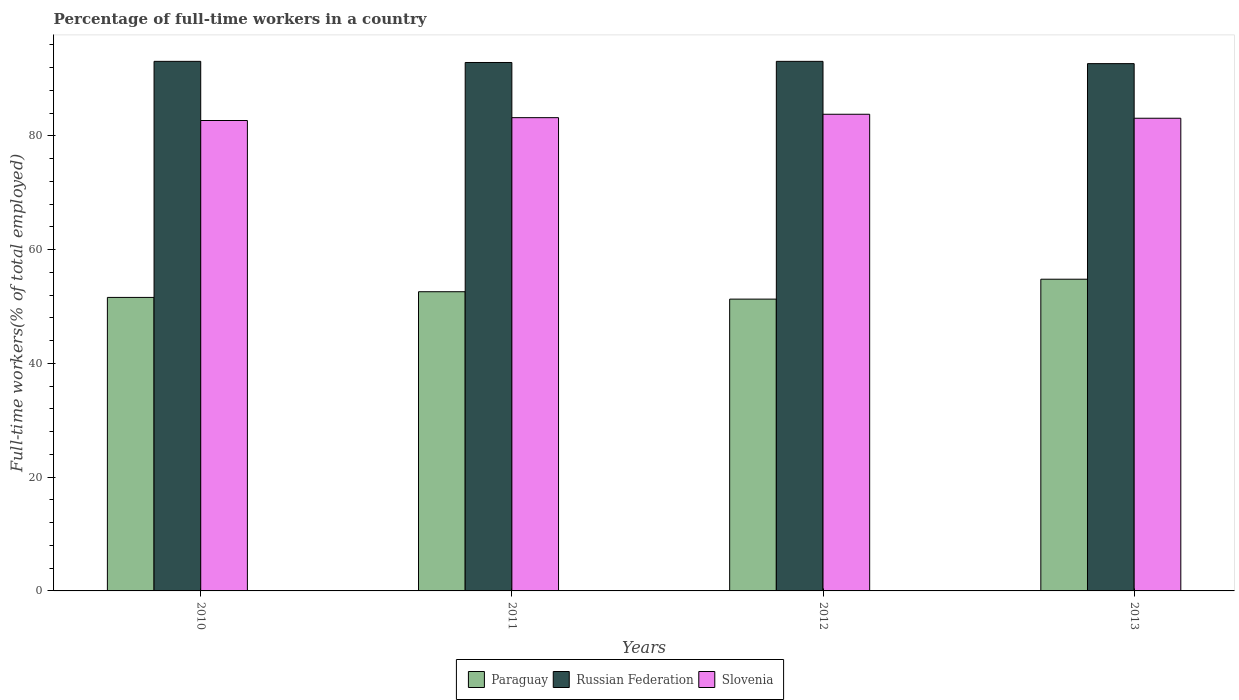Are the number of bars per tick equal to the number of legend labels?
Give a very brief answer. Yes. How many bars are there on the 3rd tick from the left?
Make the answer very short. 3. What is the percentage of full-time workers in Russian Federation in 2011?
Give a very brief answer. 92.9. Across all years, what is the maximum percentage of full-time workers in Paraguay?
Your answer should be very brief. 54.8. Across all years, what is the minimum percentage of full-time workers in Paraguay?
Your answer should be compact. 51.3. What is the total percentage of full-time workers in Slovenia in the graph?
Provide a succinct answer. 332.8. What is the difference between the percentage of full-time workers in Slovenia in 2012 and that in 2013?
Your answer should be compact. 0.7. What is the difference between the percentage of full-time workers in Slovenia in 2010 and the percentage of full-time workers in Russian Federation in 2012?
Keep it short and to the point. -10.4. What is the average percentage of full-time workers in Paraguay per year?
Give a very brief answer. 52.57. In the year 2012, what is the difference between the percentage of full-time workers in Slovenia and percentage of full-time workers in Russian Federation?
Ensure brevity in your answer.  -9.3. What is the ratio of the percentage of full-time workers in Russian Federation in 2010 to that in 2013?
Make the answer very short. 1. Is the percentage of full-time workers in Russian Federation in 2010 less than that in 2011?
Your answer should be compact. No. Is the difference between the percentage of full-time workers in Slovenia in 2010 and 2012 greater than the difference between the percentage of full-time workers in Russian Federation in 2010 and 2012?
Offer a very short reply. No. What is the difference between the highest and the second highest percentage of full-time workers in Slovenia?
Your answer should be compact. 0.6. What is the difference between the highest and the lowest percentage of full-time workers in Paraguay?
Your answer should be very brief. 3.5. In how many years, is the percentage of full-time workers in Slovenia greater than the average percentage of full-time workers in Slovenia taken over all years?
Ensure brevity in your answer.  1. What does the 2nd bar from the left in 2012 represents?
Offer a very short reply. Russian Federation. What does the 3rd bar from the right in 2012 represents?
Your answer should be compact. Paraguay. Is it the case that in every year, the sum of the percentage of full-time workers in Russian Federation and percentage of full-time workers in Slovenia is greater than the percentage of full-time workers in Paraguay?
Offer a terse response. Yes. What is the difference between two consecutive major ticks on the Y-axis?
Provide a short and direct response. 20. Does the graph contain any zero values?
Your answer should be compact. No. What is the title of the graph?
Ensure brevity in your answer.  Percentage of full-time workers in a country. What is the label or title of the Y-axis?
Offer a terse response. Full-time workers(% of total employed). What is the Full-time workers(% of total employed) of Paraguay in 2010?
Provide a succinct answer. 51.6. What is the Full-time workers(% of total employed) of Russian Federation in 2010?
Your answer should be compact. 93.1. What is the Full-time workers(% of total employed) of Slovenia in 2010?
Your response must be concise. 82.7. What is the Full-time workers(% of total employed) of Paraguay in 2011?
Provide a short and direct response. 52.6. What is the Full-time workers(% of total employed) of Russian Federation in 2011?
Your answer should be very brief. 92.9. What is the Full-time workers(% of total employed) of Slovenia in 2011?
Your answer should be compact. 83.2. What is the Full-time workers(% of total employed) of Paraguay in 2012?
Keep it short and to the point. 51.3. What is the Full-time workers(% of total employed) in Russian Federation in 2012?
Your answer should be compact. 93.1. What is the Full-time workers(% of total employed) in Slovenia in 2012?
Offer a terse response. 83.8. What is the Full-time workers(% of total employed) in Paraguay in 2013?
Ensure brevity in your answer.  54.8. What is the Full-time workers(% of total employed) of Russian Federation in 2013?
Offer a very short reply. 92.7. What is the Full-time workers(% of total employed) in Slovenia in 2013?
Your answer should be very brief. 83.1. Across all years, what is the maximum Full-time workers(% of total employed) of Paraguay?
Offer a very short reply. 54.8. Across all years, what is the maximum Full-time workers(% of total employed) in Russian Federation?
Give a very brief answer. 93.1. Across all years, what is the maximum Full-time workers(% of total employed) of Slovenia?
Make the answer very short. 83.8. Across all years, what is the minimum Full-time workers(% of total employed) of Paraguay?
Make the answer very short. 51.3. Across all years, what is the minimum Full-time workers(% of total employed) in Russian Federation?
Your answer should be very brief. 92.7. Across all years, what is the minimum Full-time workers(% of total employed) in Slovenia?
Provide a succinct answer. 82.7. What is the total Full-time workers(% of total employed) of Paraguay in the graph?
Make the answer very short. 210.3. What is the total Full-time workers(% of total employed) in Russian Federation in the graph?
Your answer should be very brief. 371.8. What is the total Full-time workers(% of total employed) in Slovenia in the graph?
Ensure brevity in your answer.  332.8. What is the difference between the Full-time workers(% of total employed) in Paraguay in 2010 and that in 2012?
Keep it short and to the point. 0.3. What is the difference between the Full-time workers(% of total employed) in Russian Federation in 2010 and that in 2012?
Give a very brief answer. 0. What is the difference between the Full-time workers(% of total employed) of Slovenia in 2010 and that in 2013?
Ensure brevity in your answer.  -0.4. What is the difference between the Full-time workers(% of total employed) in Slovenia in 2011 and that in 2012?
Ensure brevity in your answer.  -0.6. What is the difference between the Full-time workers(% of total employed) of Slovenia in 2011 and that in 2013?
Your response must be concise. 0.1. What is the difference between the Full-time workers(% of total employed) of Russian Federation in 2012 and that in 2013?
Provide a short and direct response. 0.4. What is the difference between the Full-time workers(% of total employed) in Slovenia in 2012 and that in 2013?
Provide a succinct answer. 0.7. What is the difference between the Full-time workers(% of total employed) of Paraguay in 2010 and the Full-time workers(% of total employed) of Russian Federation in 2011?
Keep it short and to the point. -41.3. What is the difference between the Full-time workers(% of total employed) in Paraguay in 2010 and the Full-time workers(% of total employed) in Slovenia in 2011?
Your answer should be very brief. -31.6. What is the difference between the Full-time workers(% of total employed) of Russian Federation in 2010 and the Full-time workers(% of total employed) of Slovenia in 2011?
Your answer should be very brief. 9.9. What is the difference between the Full-time workers(% of total employed) in Paraguay in 2010 and the Full-time workers(% of total employed) in Russian Federation in 2012?
Your response must be concise. -41.5. What is the difference between the Full-time workers(% of total employed) in Paraguay in 2010 and the Full-time workers(% of total employed) in Slovenia in 2012?
Give a very brief answer. -32.2. What is the difference between the Full-time workers(% of total employed) in Russian Federation in 2010 and the Full-time workers(% of total employed) in Slovenia in 2012?
Keep it short and to the point. 9.3. What is the difference between the Full-time workers(% of total employed) of Paraguay in 2010 and the Full-time workers(% of total employed) of Russian Federation in 2013?
Provide a succinct answer. -41.1. What is the difference between the Full-time workers(% of total employed) in Paraguay in 2010 and the Full-time workers(% of total employed) in Slovenia in 2013?
Your response must be concise. -31.5. What is the difference between the Full-time workers(% of total employed) of Paraguay in 2011 and the Full-time workers(% of total employed) of Russian Federation in 2012?
Offer a terse response. -40.5. What is the difference between the Full-time workers(% of total employed) in Paraguay in 2011 and the Full-time workers(% of total employed) in Slovenia in 2012?
Your response must be concise. -31.2. What is the difference between the Full-time workers(% of total employed) of Russian Federation in 2011 and the Full-time workers(% of total employed) of Slovenia in 2012?
Offer a very short reply. 9.1. What is the difference between the Full-time workers(% of total employed) of Paraguay in 2011 and the Full-time workers(% of total employed) of Russian Federation in 2013?
Offer a very short reply. -40.1. What is the difference between the Full-time workers(% of total employed) of Paraguay in 2011 and the Full-time workers(% of total employed) of Slovenia in 2013?
Provide a succinct answer. -30.5. What is the difference between the Full-time workers(% of total employed) in Russian Federation in 2011 and the Full-time workers(% of total employed) in Slovenia in 2013?
Your answer should be compact. 9.8. What is the difference between the Full-time workers(% of total employed) of Paraguay in 2012 and the Full-time workers(% of total employed) of Russian Federation in 2013?
Your answer should be compact. -41.4. What is the difference between the Full-time workers(% of total employed) of Paraguay in 2012 and the Full-time workers(% of total employed) of Slovenia in 2013?
Give a very brief answer. -31.8. What is the average Full-time workers(% of total employed) of Paraguay per year?
Offer a terse response. 52.58. What is the average Full-time workers(% of total employed) of Russian Federation per year?
Keep it short and to the point. 92.95. What is the average Full-time workers(% of total employed) of Slovenia per year?
Offer a terse response. 83.2. In the year 2010, what is the difference between the Full-time workers(% of total employed) of Paraguay and Full-time workers(% of total employed) of Russian Federation?
Ensure brevity in your answer.  -41.5. In the year 2010, what is the difference between the Full-time workers(% of total employed) of Paraguay and Full-time workers(% of total employed) of Slovenia?
Provide a succinct answer. -31.1. In the year 2010, what is the difference between the Full-time workers(% of total employed) in Russian Federation and Full-time workers(% of total employed) in Slovenia?
Your response must be concise. 10.4. In the year 2011, what is the difference between the Full-time workers(% of total employed) of Paraguay and Full-time workers(% of total employed) of Russian Federation?
Make the answer very short. -40.3. In the year 2011, what is the difference between the Full-time workers(% of total employed) in Paraguay and Full-time workers(% of total employed) in Slovenia?
Offer a very short reply. -30.6. In the year 2012, what is the difference between the Full-time workers(% of total employed) in Paraguay and Full-time workers(% of total employed) in Russian Federation?
Your answer should be very brief. -41.8. In the year 2012, what is the difference between the Full-time workers(% of total employed) of Paraguay and Full-time workers(% of total employed) of Slovenia?
Make the answer very short. -32.5. In the year 2013, what is the difference between the Full-time workers(% of total employed) in Paraguay and Full-time workers(% of total employed) in Russian Federation?
Give a very brief answer. -37.9. In the year 2013, what is the difference between the Full-time workers(% of total employed) of Paraguay and Full-time workers(% of total employed) of Slovenia?
Provide a short and direct response. -28.3. In the year 2013, what is the difference between the Full-time workers(% of total employed) in Russian Federation and Full-time workers(% of total employed) in Slovenia?
Keep it short and to the point. 9.6. What is the ratio of the Full-time workers(% of total employed) of Russian Federation in 2010 to that in 2011?
Give a very brief answer. 1. What is the ratio of the Full-time workers(% of total employed) of Slovenia in 2010 to that in 2011?
Provide a succinct answer. 0.99. What is the ratio of the Full-time workers(% of total employed) of Paraguay in 2010 to that in 2012?
Make the answer very short. 1.01. What is the ratio of the Full-time workers(% of total employed) in Russian Federation in 2010 to that in 2012?
Offer a very short reply. 1. What is the ratio of the Full-time workers(% of total employed) of Slovenia in 2010 to that in 2012?
Offer a terse response. 0.99. What is the ratio of the Full-time workers(% of total employed) of Paraguay in 2010 to that in 2013?
Ensure brevity in your answer.  0.94. What is the ratio of the Full-time workers(% of total employed) of Russian Federation in 2010 to that in 2013?
Your response must be concise. 1. What is the ratio of the Full-time workers(% of total employed) in Slovenia in 2010 to that in 2013?
Provide a succinct answer. 1. What is the ratio of the Full-time workers(% of total employed) of Paraguay in 2011 to that in 2012?
Provide a succinct answer. 1.03. What is the ratio of the Full-time workers(% of total employed) in Russian Federation in 2011 to that in 2012?
Make the answer very short. 1. What is the ratio of the Full-time workers(% of total employed) in Slovenia in 2011 to that in 2012?
Offer a very short reply. 0.99. What is the ratio of the Full-time workers(% of total employed) of Paraguay in 2011 to that in 2013?
Provide a succinct answer. 0.96. What is the ratio of the Full-time workers(% of total employed) in Paraguay in 2012 to that in 2013?
Make the answer very short. 0.94. What is the ratio of the Full-time workers(% of total employed) in Slovenia in 2012 to that in 2013?
Offer a very short reply. 1.01. What is the difference between the highest and the second highest Full-time workers(% of total employed) in Paraguay?
Give a very brief answer. 2.2. What is the difference between the highest and the lowest Full-time workers(% of total employed) in Russian Federation?
Your answer should be compact. 0.4. What is the difference between the highest and the lowest Full-time workers(% of total employed) in Slovenia?
Your answer should be very brief. 1.1. 